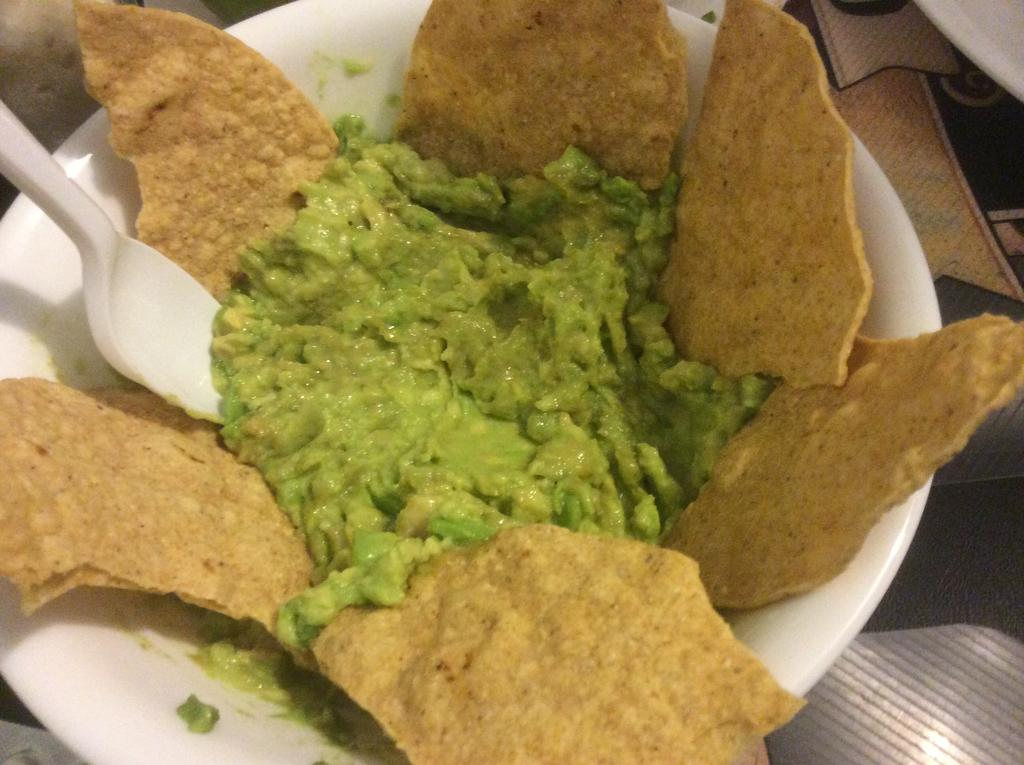What is in the bowl that is visible in the image? There is a bowl with papads in the image. What other type of food is in the bowl? There is a green salad in the bowl. What utensil is present in the image? There is a white spoon in the image. Where is the bowl placed? The bowl is placed on a table. What is the name of the territory where the papads were made in the image? There is no information about the origin or territory of the papads in the image. 